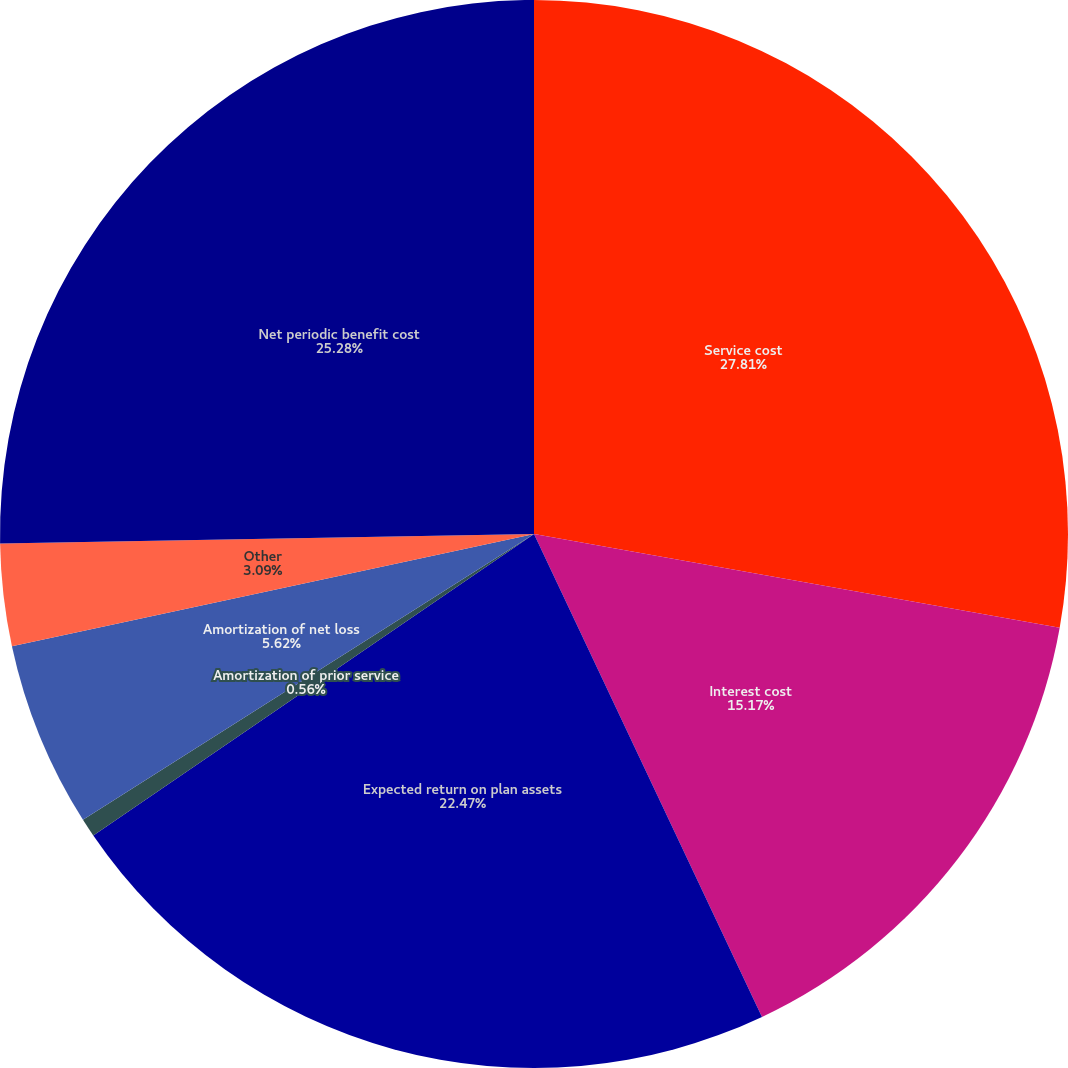<chart> <loc_0><loc_0><loc_500><loc_500><pie_chart><fcel>Service cost<fcel>Interest cost<fcel>Expected return on plan assets<fcel>Amortization of prior service<fcel>Amortization of net loss<fcel>Other<fcel>Net periodic benefit cost<nl><fcel>27.81%<fcel>15.17%<fcel>22.47%<fcel>0.56%<fcel>5.62%<fcel>3.09%<fcel>25.28%<nl></chart> 